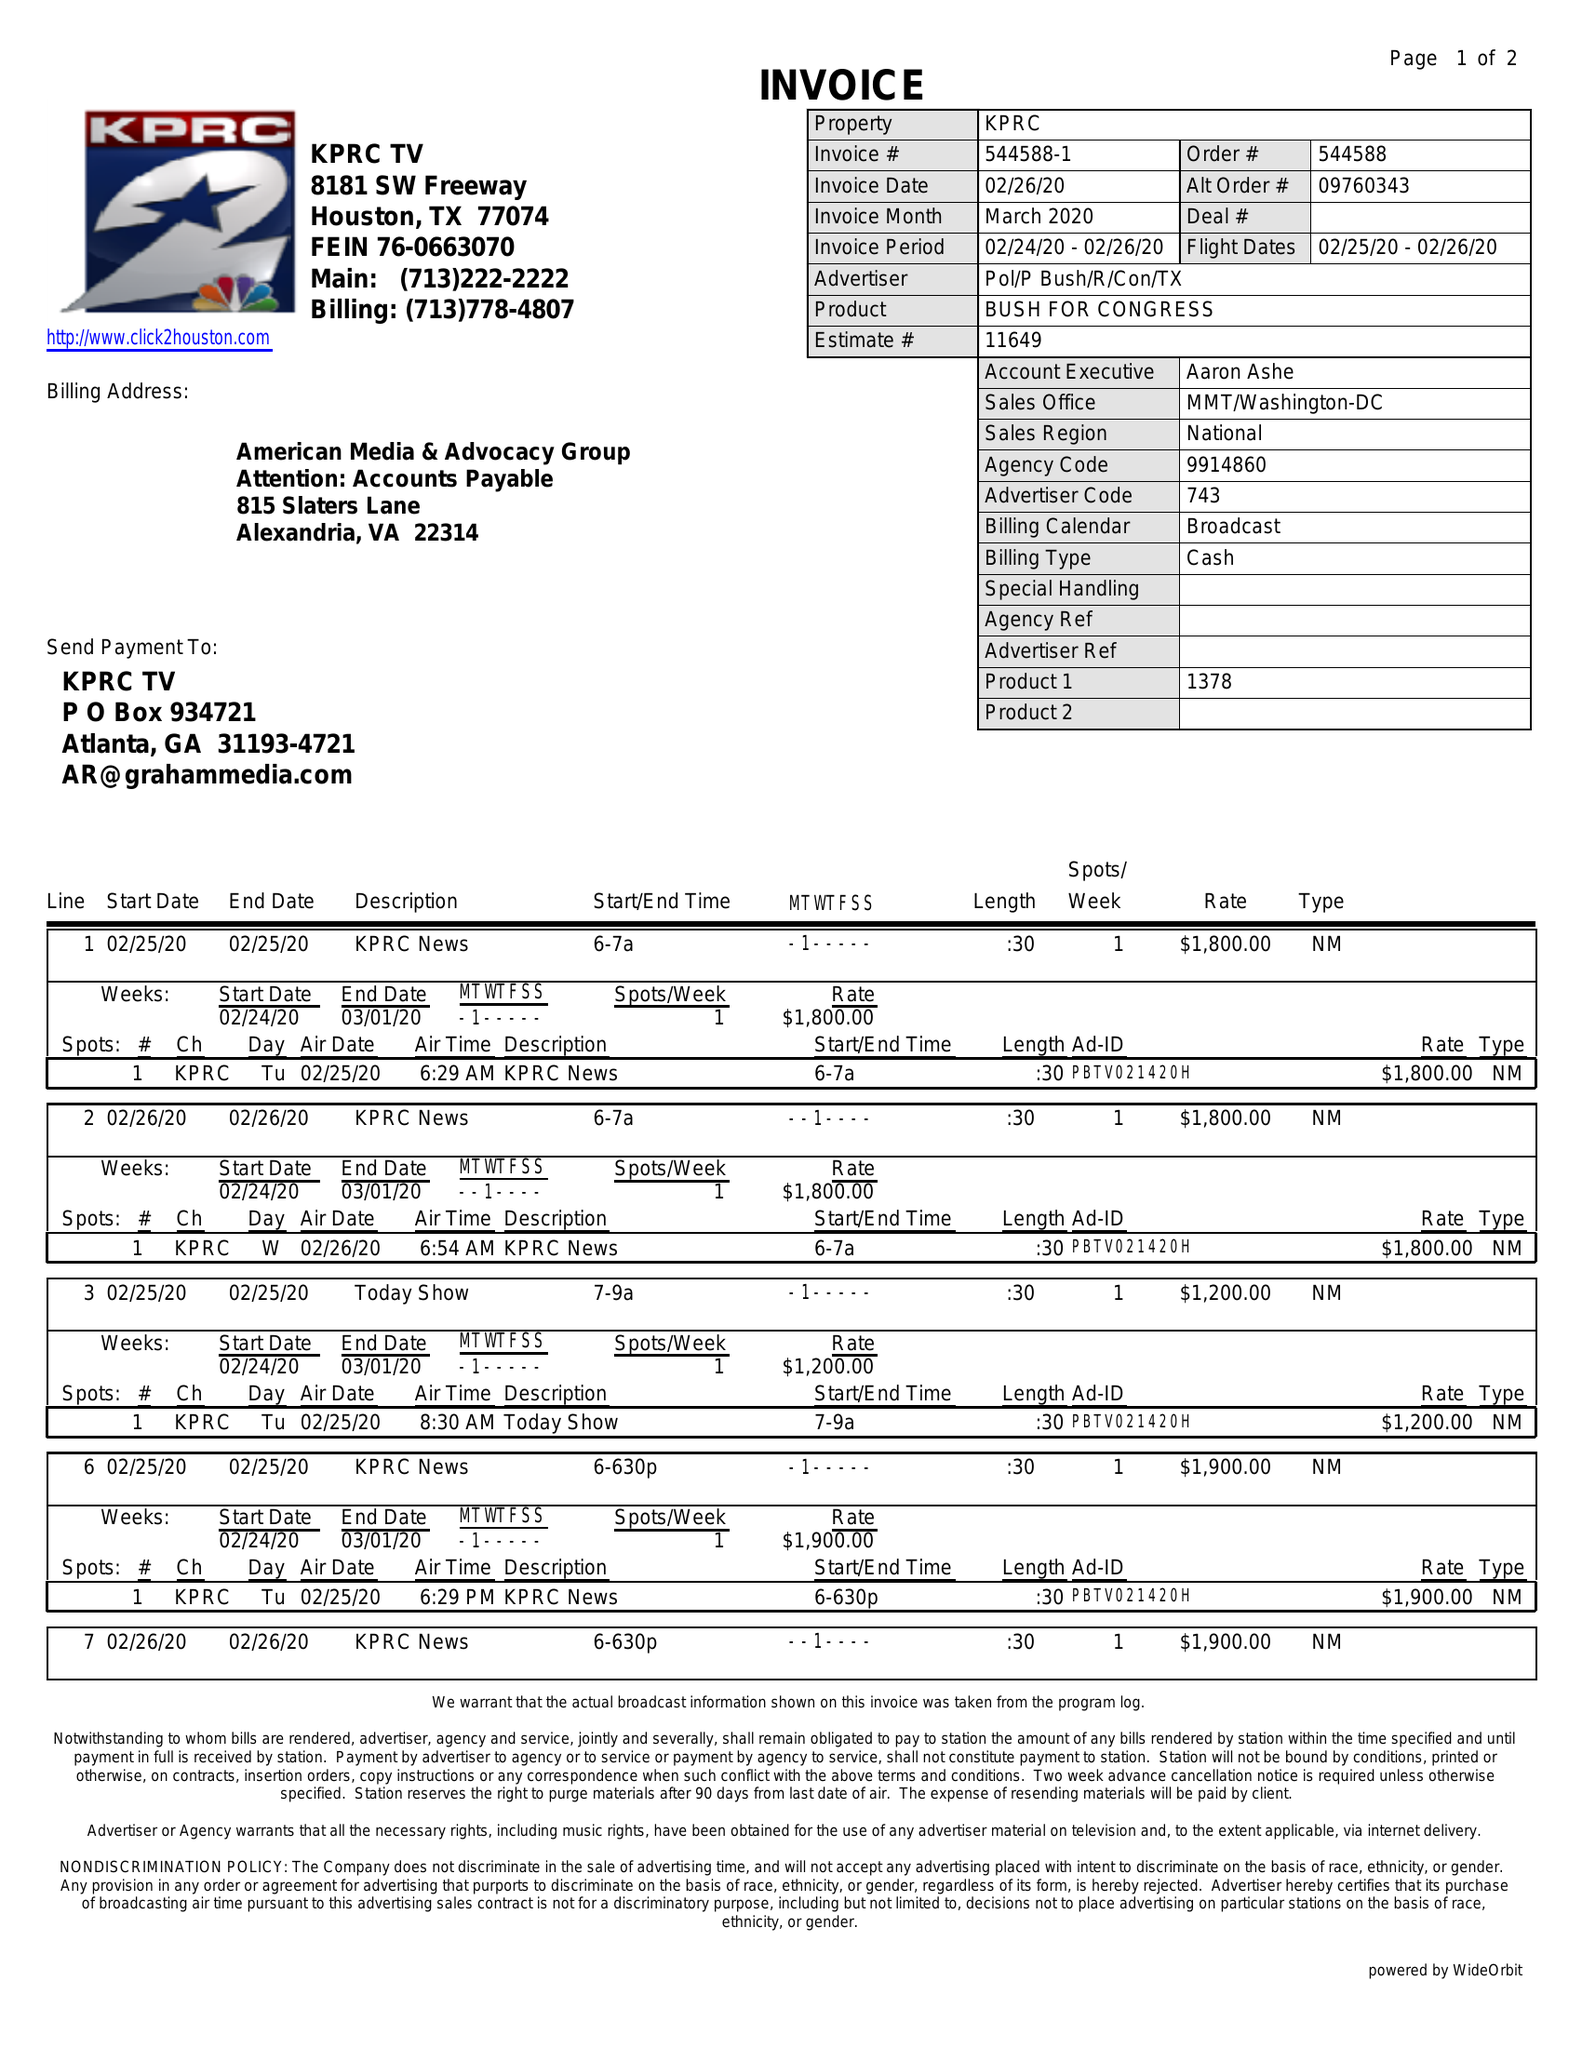What is the value for the gross_amount?
Answer the question using a single word or phrase. 15500.00 